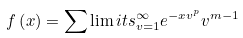<formula> <loc_0><loc_0><loc_500><loc_500>f \left ( x \right ) = \sum \lim i t s _ { v = 1 } ^ { \infty } { { e ^ { - x { v ^ { p } } } } { v ^ { m - 1 } } }</formula> 